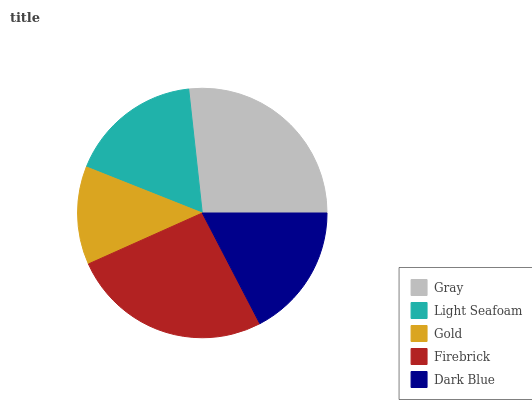Is Gold the minimum?
Answer yes or no. Yes. Is Gray the maximum?
Answer yes or no. Yes. Is Light Seafoam the minimum?
Answer yes or no. No. Is Light Seafoam the maximum?
Answer yes or no. No. Is Gray greater than Light Seafoam?
Answer yes or no. Yes. Is Light Seafoam less than Gray?
Answer yes or no. Yes. Is Light Seafoam greater than Gray?
Answer yes or no. No. Is Gray less than Light Seafoam?
Answer yes or no. No. Is Dark Blue the high median?
Answer yes or no. Yes. Is Dark Blue the low median?
Answer yes or no. Yes. Is Gray the high median?
Answer yes or no. No. Is Firebrick the low median?
Answer yes or no. No. 